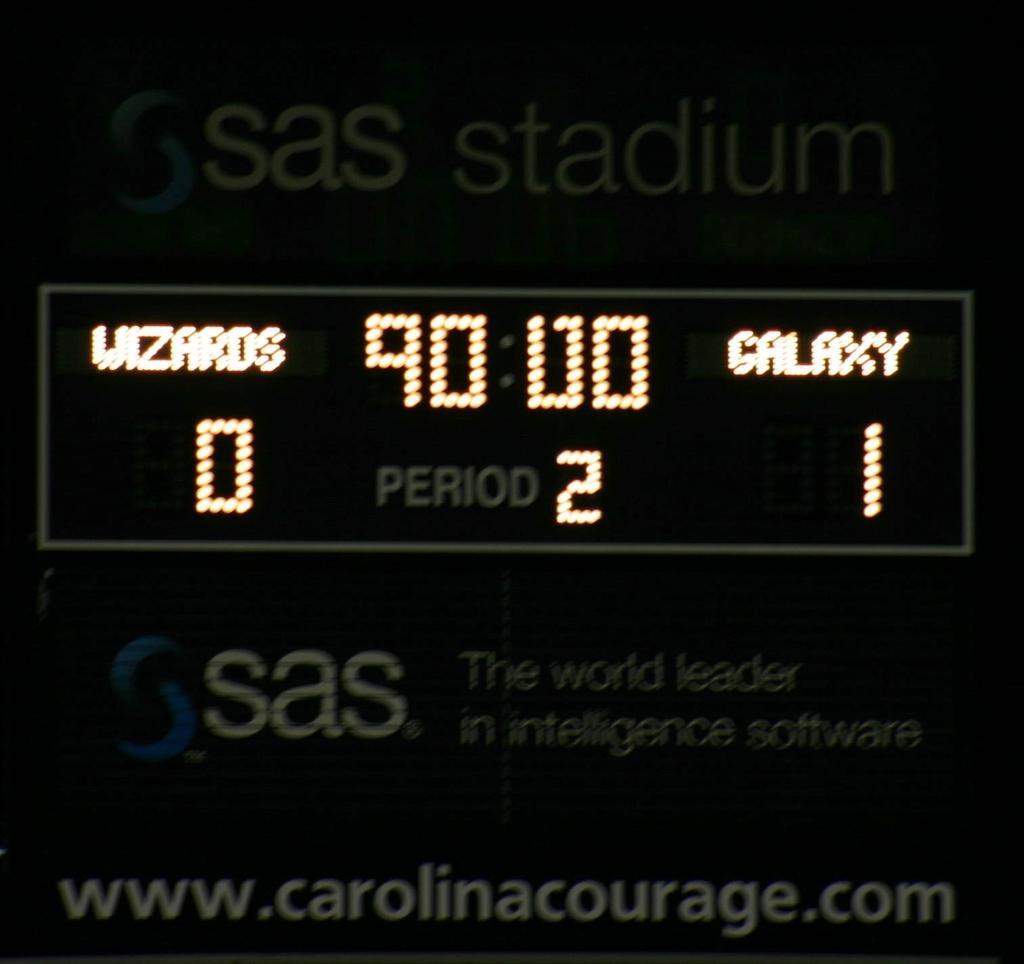Could you give a brief overview of what you see in this image? In the center of the image, there is a screen. On the screen, we can see some numbers and some text. And we can see some text at the top and bottom of the screen. 